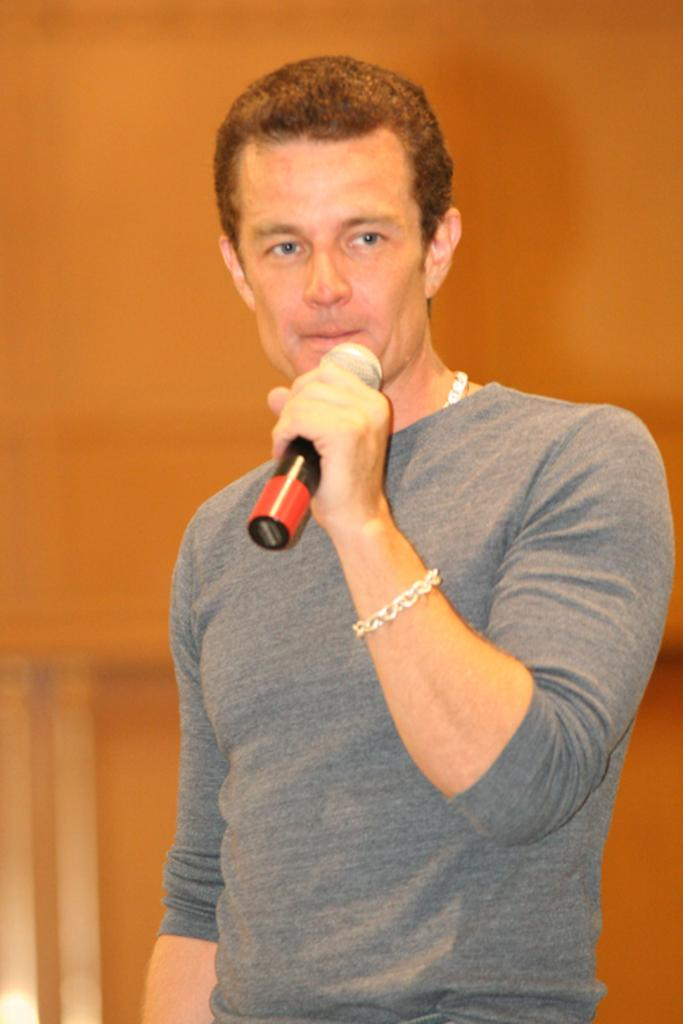What is the person in the image doing? The person is standing in the image and holding a mic. What can be seen in the background of the image? There is a wall in the background of the image. What type of crack is visible on the wall in the image? There is no crack visible on the wall in the image. 